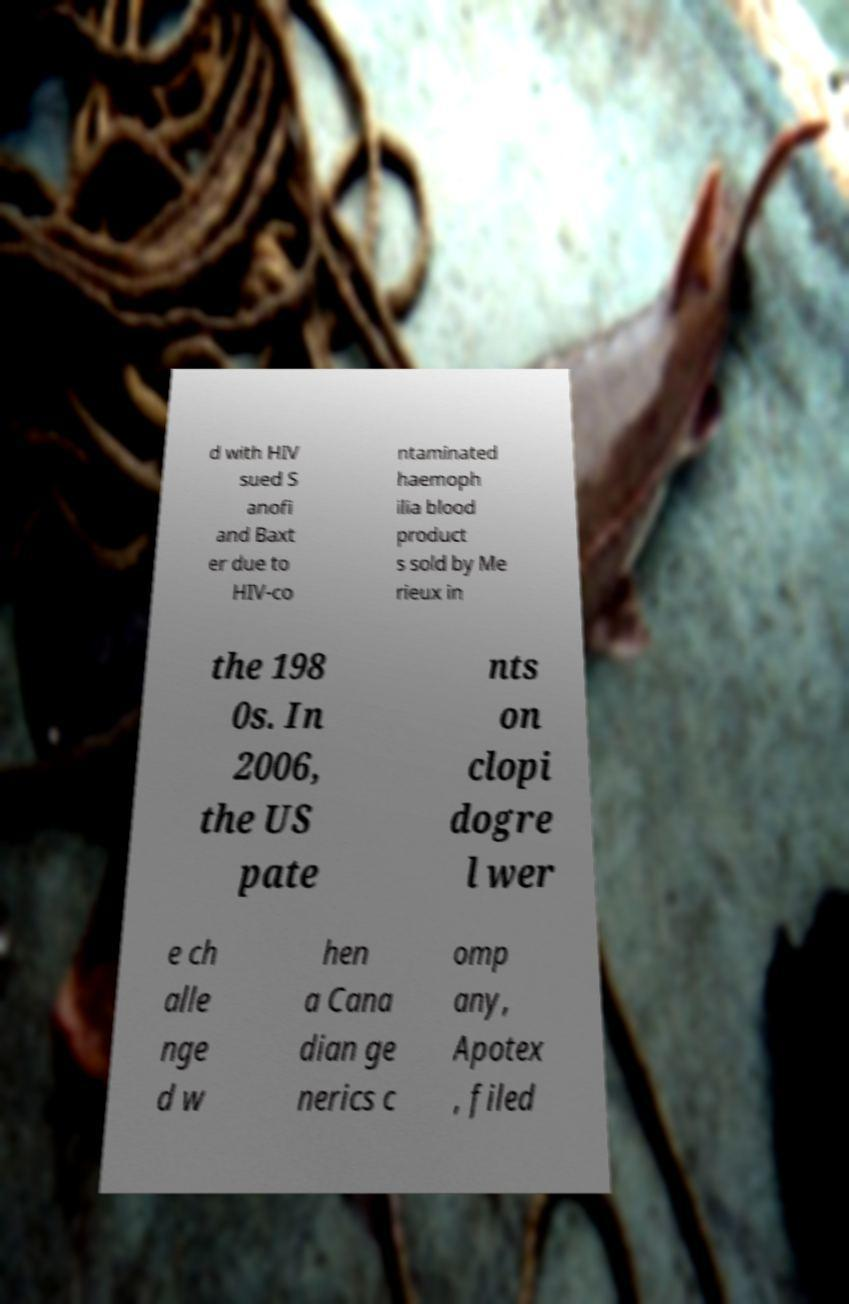There's text embedded in this image that I need extracted. Can you transcribe it verbatim? d with HIV sued S anofi and Baxt er due to HIV-co ntaminated haemoph ilia blood product s sold by Me rieux in the 198 0s. In 2006, the US pate nts on clopi dogre l wer e ch alle nge d w hen a Cana dian ge nerics c omp any, Apotex , filed 